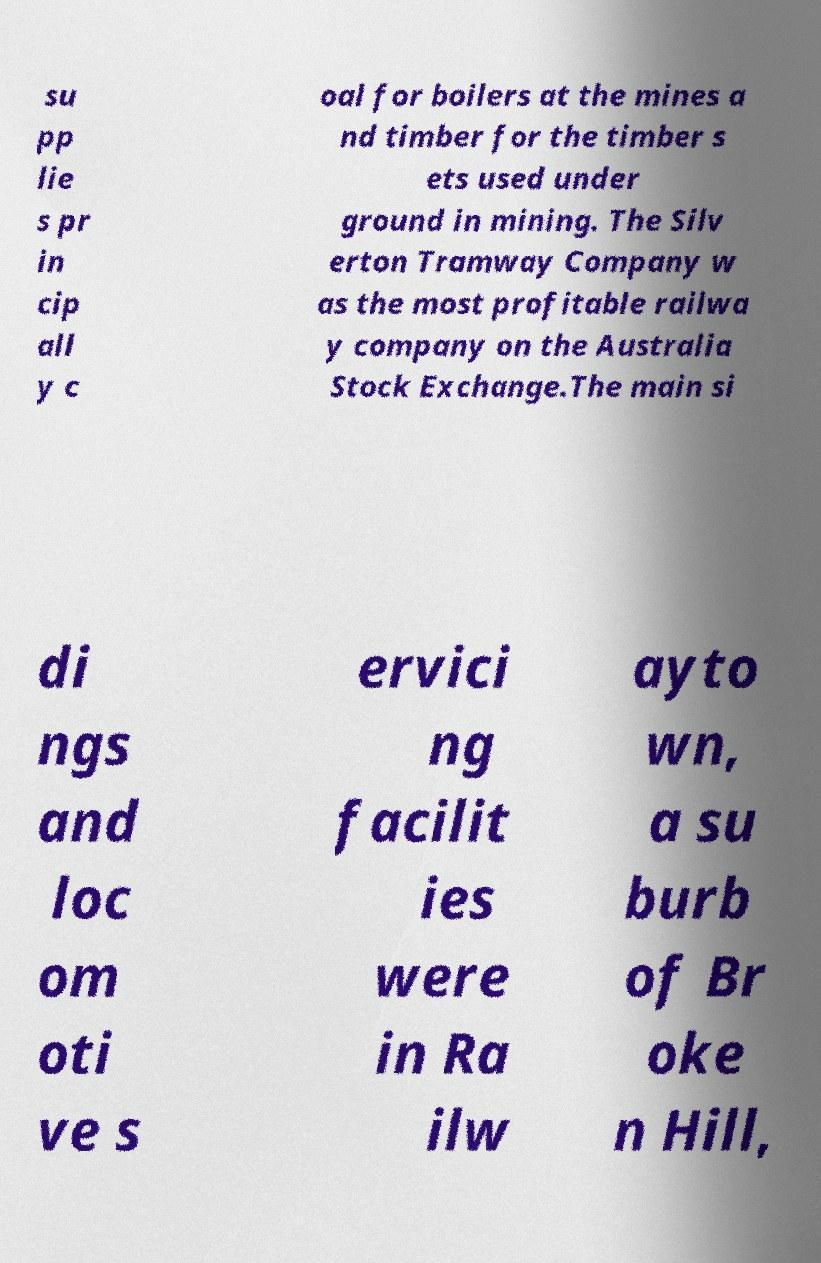What messages or text are displayed in this image? I need them in a readable, typed format. su pp lie s pr in cip all y c oal for boilers at the mines a nd timber for the timber s ets used under ground in mining. The Silv erton Tramway Company w as the most profitable railwa y company on the Australia Stock Exchange.The main si di ngs and loc om oti ve s ervici ng facilit ies were in Ra ilw ayto wn, a su burb of Br oke n Hill, 